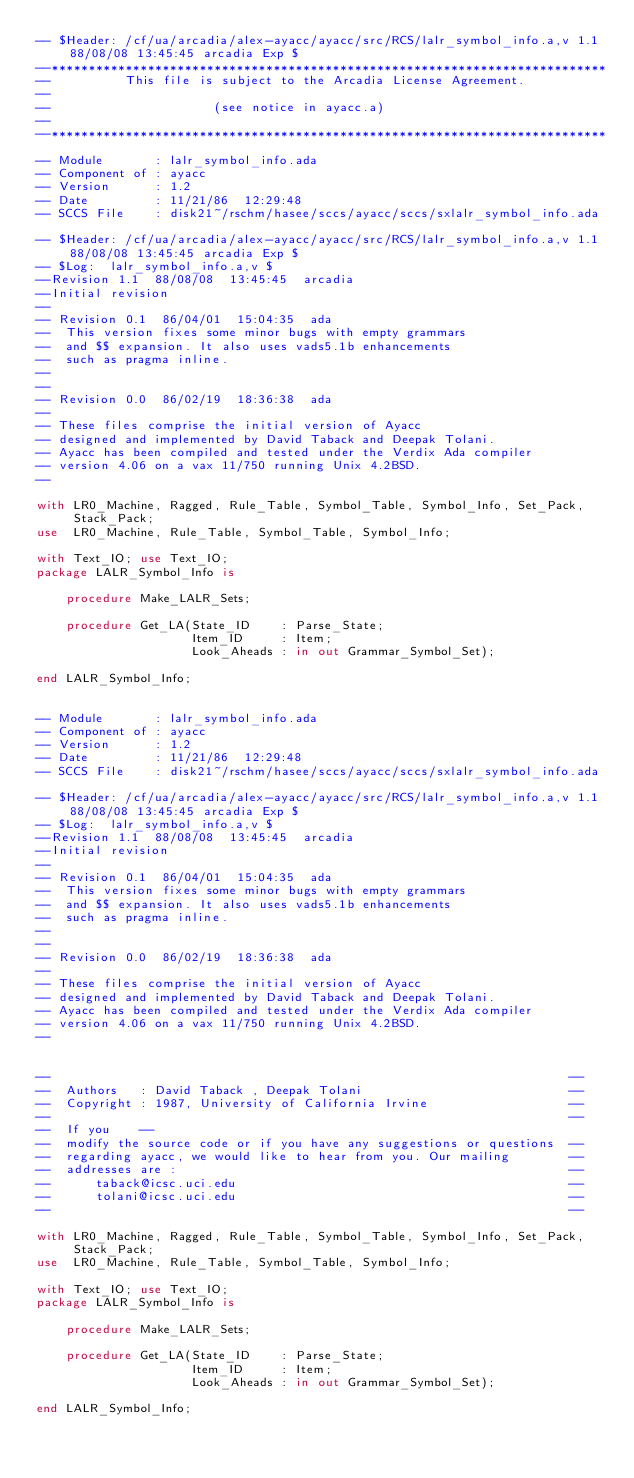Convert code to text. <code><loc_0><loc_0><loc_500><loc_500><_Ada_>-- $Header: /cf/ua/arcadia/alex-ayacc/ayacc/src/RCS/lalr_symbol_info.a,v 1.1 88/08/08 13:45:45 arcadia Exp $ 
--*************************************************************************** 
--          This file is subject to the Arcadia License Agreement. 
--
--                      (see notice in ayacc.a)
--
--*************************************************************************** 

-- Module       : lalr_symbol_info.ada
-- Component of : ayacc
-- Version      : 1.2
-- Date         : 11/21/86  12:29:48
-- SCCS File    : disk21~/rschm/hasee/sccs/ayacc/sccs/sxlalr_symbol_info.ada

-- $Header: /cf/ua/arcadia/alex-ayacc/ayacc/src/RCS/lalr_symbol_info.a,v 1.1 88/08/08 13:45:45 arcadia Exp $ 
-- $Log:	lalr_symbol_info.a,v $
--Revision 1.1  88/08/08  13:45:45  arcadia
--Initial revision
--
-- Revision 0.1  86/04/01  15:04:35  ada
--  This version fixes some minor bugs with empty grammars 
--  and $$ expansion. It also uses vads5.1b enhancements 
--  such as pragma inline. 
-- 
-- 
-- Revision 0.0  86/02/19  18:36:38  ada
-- 
-- These files comprise the initial version of Ayacc
-- designed and implemented by David Taback and Deepak Tolani.
-- Ayacc has been compiled and tested under the Verdix Ada compiler
-- version 4.06 on a vax 11/750 running Unix 4.2BSD.
--  

with LR0_Machine, Ragged, Rule_Table, Symbol_Table, Symbol_Info, Set_Pack, 
     Stack_Pack; 
use  LR0_Machine, Rule_Table, Symbol_Table, Symbol_Info; 

with Text_IO; use Text_IO; 
package LALR_Symbol_Info is 

    procedure Make_LALR_Sets; 

    procedure Get_LA(State_ID    : Parse_State; 
                     Item_ID     : Item; 
                     Look_Aheads : in out Grammar_Symbol_Set);

end LALR_Symbol_Info; 


-- Module       : lalr_symbol_info.ada
-- Component of : ayacc
-- Version      : 1.2
-- Date         : 11/21/86  12:29:48
-- SCCS File    : disk21~/rschm/hasee/sccs/ayacc/sccs/sxlalr_symbol_info.ada

-- $Header: /cf/ua/arcadia/alex-ayacc/ayacc/src/RCS/lalr_symbol_info.a,v 1.1 88/08/08 13:45:45 arcadia Exp $ 
-- $Log:	lalr_symbol_info.a,v $
--Revision 1.1  88/08/08  13:45:45  arcadia
--Initial revision
--
-- Revision 0.1  86/04/01  15:04:35  ada
--  This version fixes some minor bugs with empty grammars 
--  and $$ expansion. It also uses vads5.1b enhancements 
--  such as pragma inline. 
-- 
-- 
-- Revision 0.0  86/02/19  18:36:38  ada
-- 
-- These files comprise the initial version of Ayacc
-- designed and implemented by David Taback and Deepak Tolani.
-- Ayacc has been compiled and tested under the Verdix Ada compiler
-- version 4.06 on a vax 11/750 running Unix 4.2BSD.
--  


--                                                                      --
--  Authors   : David Taback , Deepak Tolani                            --
--  Copyright : 1987, University of California Irvine                   --
--                                                                      -- 
--  If you    -- 
--  modify the source code or if you have any suggestions or questions  -- 
--  regarding ayacc, we would like to hear from you. Our mailing        -- 
--  addresses are :                                                     -- 
--      taback@icsc.uci.edu                                             -- 
--      tolani@icsc.uci.edu                                             --   
--                                                                      --  

with LR0_Machine, Ragged, Rule_Table, Symbol_Table, Symbol_Info, Set_Pack, 
     Stack_Pack; 
use  LR0_Machine, Rule_Table, Symbol_Table, Symbol_Info; 

with Text_IO; use Text_IO; 
package LALR_Symbol_Info is 

    procedure Make_LALR_Sets; 

    procedure Get_LA(State_ID    : Parse_State; 
                     Item_ID     : Item; 
                     Look_Aheads : in out Grammar_Symbol_Set);

end LALR_Symbol_Info; 

</code> 